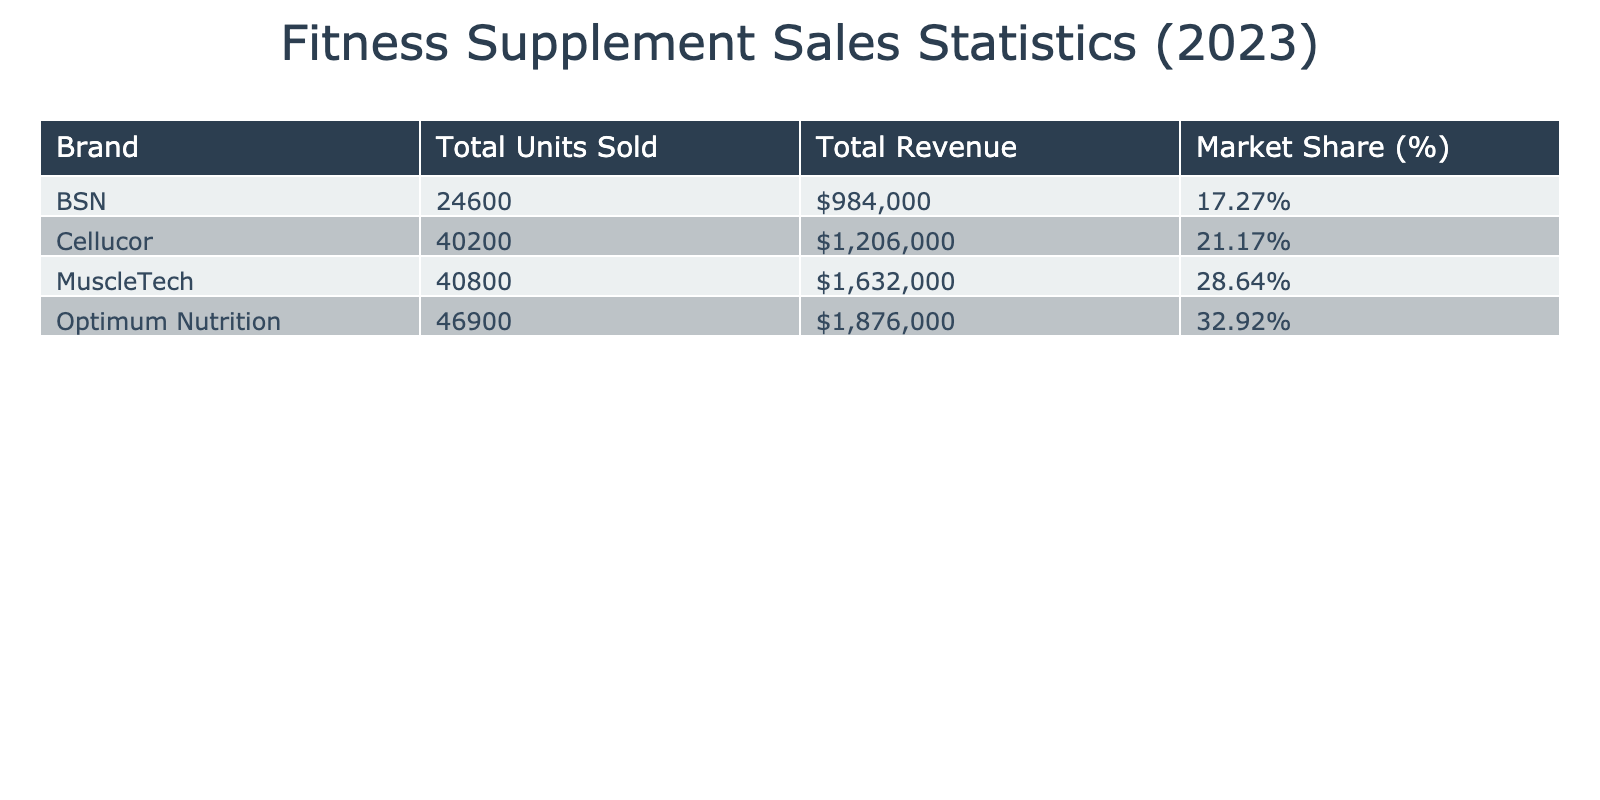What brand had the highest total revenue in 2023? To find the brand with the highest total revenue, I looked at the revenue values in the table. Optimum Nutrition has the highest revenue at $1,779,000.
Answer: Optimum Nutrition How many total units of Cellucor were sold in 2023? I summed the sales units for Cellucor across all months listed: 2800 + 2900 + 3000 + 3100 + 3200 + 3300 + 3400 + 3500 + 3600 + 3700 + 3800 + 3900 = 38,400.
Answer: 38,400 Which supplement did BSN sell the least in terms of total units sold? I examined the sales units for BSN's True Mass across all months, finding that it sold the least with 19,900 units in total over the year.
Answer: True Mass What is the average market share percentage for MuscleTech in 2023? First, I found MuscleTech's revenue, which is $1,559,000. The total revenue for all brands is $4,800,000. To calculate the average market share, I divided MuscleTech's revenue by the total revenue and multiplied by 100: (1,559,000 / 4,800,000) * 100 = 32.56%.
Answer: 32.56% Did Cellucor's sales revenue exceed BSN's revenue in any month? I compared the monthly sales revenue for both brands. Cellucor's revenue was higher than BSN's in all months of 2023.
Answer: Yes What was the total revenue from weight gain products sold in 2023? I added the sales revenue of BSN True Mass (each month) and found it: 60000 + 64000 + 68000 + 72000 + 76000 + 80000 + 84000 + 88000 + 92000 + 96000 + 100000 + 104000 = $1,436,000.
Answer: $1,436,000 How much more revenue did Optimum Nutrition generate compared to Cellucor in December? In December, Optimum Nutrition generated $180,000 while Cellucor generated $117,000. The difference is $180,000 - $117,000 = $63,000.
Answer: $63,000 What percentage of the total sales units did the product 'Gold Standard Whey' contribute? The total sales units for 'Gold Standard Whey' is 48,700 units. The total sales units from all brands is 122,000 units. To find the percentage, (48700 / 122000) * 100 = 39.93%.
Answer: 39.93% Which month recorded the lowest sales revenue for MuscleTech? Reviewing the monthly sales revenue for MuscleTech, the lowest was recorded in January at $108,000.
Answer: January 